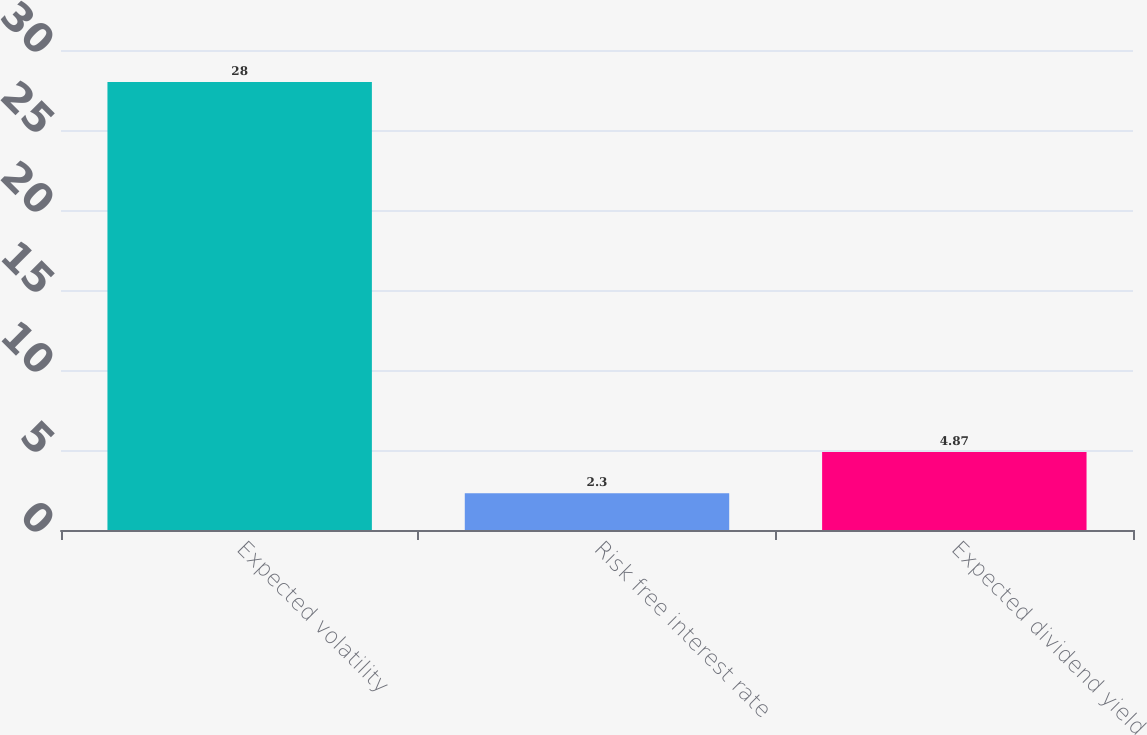<chart> <loc_0><loc_0><loc_500><loc_500><bar_chart><fcel>Expected volatility<fcel>Risk free interest rate<fcel>Expected dividend yield<nl><fcel>28<fcel>2.3<fcel>4.87<nl></chart> 